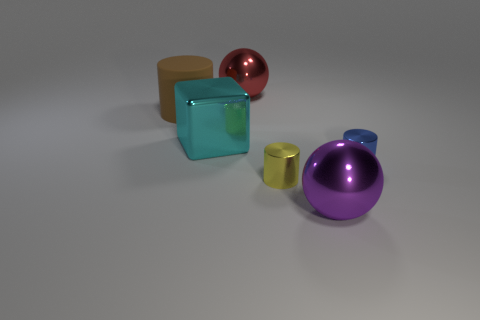Add 4 red objects. How many objects exist? 10 Subtract all blocks. How many objects are left? 5 Add 6 big red balls. How many big red balls are left? 7 Add 6 large brown matte objects. How many large brown matte objects exist? 7 Subtract 1 yellow cylinders. How many objects are left? 5 Subtract all tiny blue metallic balls. Subtract all yellow cylinders. How many objects are left? 5 